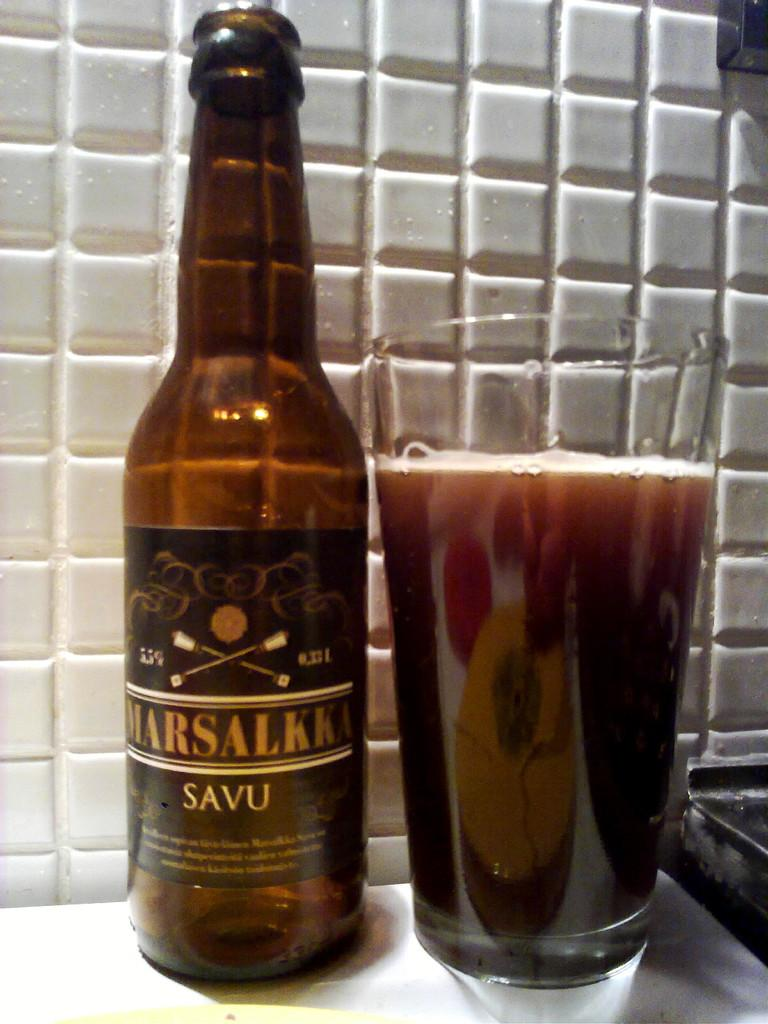<image>
Offer a succinct explanation of the picture presented. A bottle marked SAVU sits next to a glass filled with the beverage. 